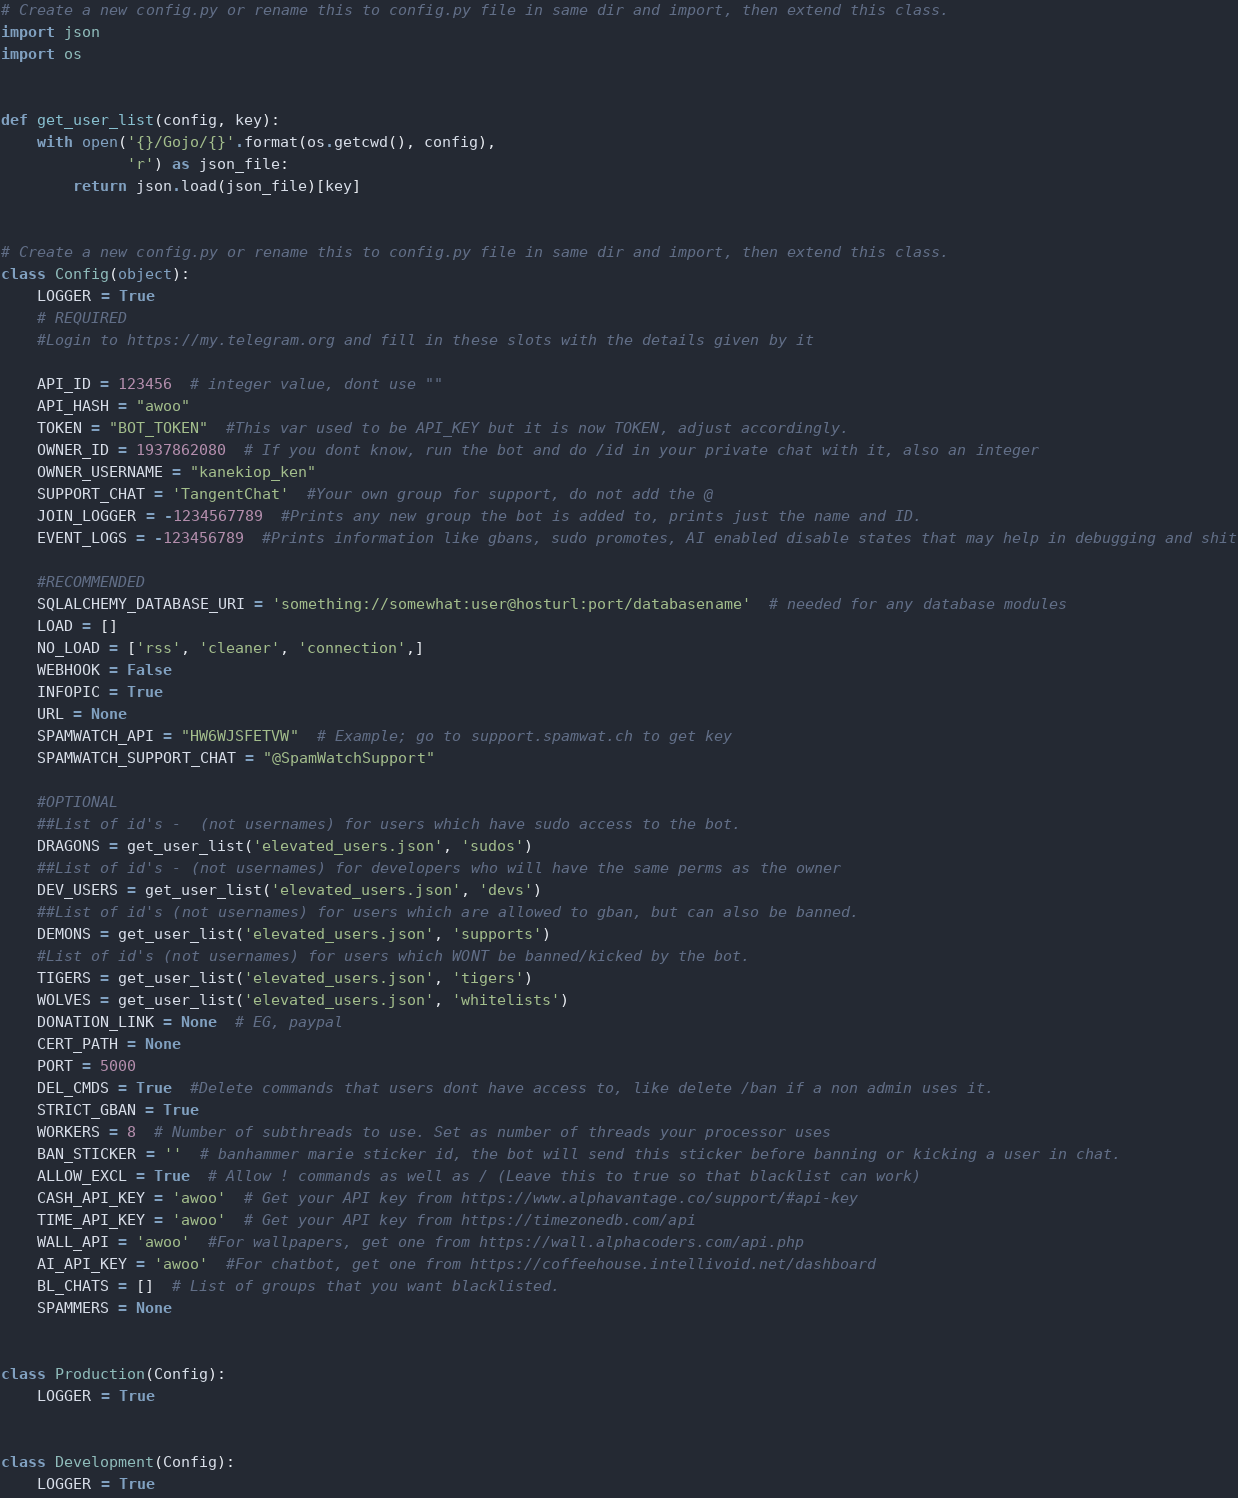<code> <loc_0><loc_0><loc_500><loc_500><_Python_># Create a new config.py or rename this to config.py file in same dir and import, then extend this class.
import json
import os


def get_user_list(config, key):
    with open('{}/Gojo/{}'.format(os.getcwd(), config),
              'r') as json_file:
        return json.load(json_file)[key]


# Create a new config.py or rename this to config.py file in same dir and import, then extend this class.
class Config(object):
    LOGGER = True
    # REQUIRED
    #Login to https://my.telegram.org and fill in these slots with the details given by it

    API_ID = 123456  # integer value, dont use ""
    API_HASH = "awoo"
    TOKEN = "BOT_TOKEN"  #This var used to be API_KEY but it is now TOKEN, adjust accordingly.
    OWNER_ID = 1937862080  # If you dont know, run the bot and do /id in your private chat with it, also an integer
    OWNER_USERNAME = "kanekiop_ken"
    SUPPORT_CHAT = 'TangentChat'  #Your own group for support, do not add the @
    JOIN_LOGGER = -1234567789  #Prints any new group the bot is added to, prints just the name and ID.
    EVENT_LOGS = -123456789  #Prints information like gbans, sudo promotes, AI enabled disable states that may help in debugging and shit

    #RECOMMENDED
    SQLALCHEMY_DATABASE_URI = 'something://somewhat:user@hosturl:port/databasename'  # needed for any database modules
    LOAD = []
    NO_LOAD = ['rss', 'cleaner', 'connection',]
    WEBHOOK = False
    INFOPIC = True
    URL = None
    SPAMWATCH_API = "HW6WJSFETVW"  # Example; go to support.spamwat.ch to get key
    SPAMWATCH_SUPPORT_CHAT = "@SpamWatchSupport"

    #OPTIONAL
    ##List of id's -  (not usernames) for users which have sudo access to the bot.
    DRAGONS = get_user_list('elevated_users.json', 'sudos')
    ##List of id's - (not usernames) for developers who will have the same perms as the owner
    DEV_USERS = get_user_list('elevated_users.json', 'devs')
    ##List of id's (not usernames) for users which are allowed to gban, but can also be banned.
    DEMONS = get_user_list('elevated_users.json', 'supports')
    #List of id's (not usernames) for users which WONT be banned/kicked by the bot.
    TIGERS = get_user_list('elevated_users.json', 'tigers')
    WOLVES = get_user_list('elevated_users.json', 'whitelists')
    DONATION_LINK = None  # EG, paypal
    CERT_PATH = None
    PORT = 5000
    DEL_CMDS = True  #Delete commands that users dont have access to, like delete /ban if a non admin uses it.
    STRICT_GBAN = True
    WORKERS = 8  # Number of subthreads to use. Set as number of threads your processor uses
    BAN_STICKER = ''  # banhammer marie sticker id, the bot will send this sticker before banning or kicking a user in chat.
    ALLOW_EXCL = True  # Allow ! commands as well as / (Leave this to true so that blacklist can work)
    CASH_API_KEY = 'awoo'  # Get your API key from https://www.alphavantage.co/support/#api-key
    TIME_API_KEY = 'awoo'  # Get your API key from https://timezonedb.com/api
    WALL_API = 'awoo'  #For wallpapers, get one from https://wall.alphacoders.com/api.php
    AI_API_KEY = 'awoo'  #For chatbot, get one from https://coffeehouse.intellivoid.net/dashboard
    BL_CHATS = []  # List of groups that you want blacklisted.
    SPAMMERS = None


class Production(Config):
    LOGGER = True


class Development(Config):
    LOGGER = True
</code> 